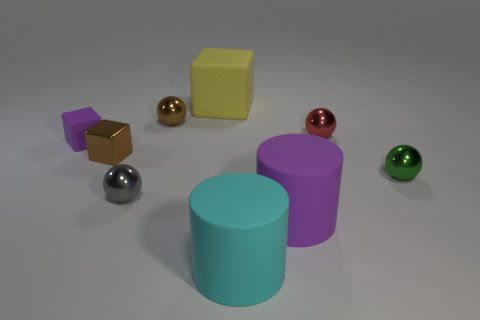What shape is the purple rubber object that is on the left side of the big cyan object? The purple object to the left of the large cyan cylinder is indeed a cube. It has a matte surface which suggests it could be made of rubber, and its geometrical shape is characterized by equal width, height, and depth, demonstrating the defining features of a cube. 